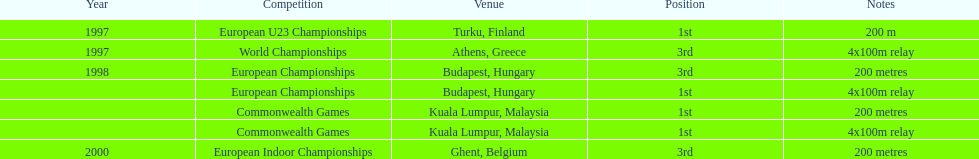List the other competitions besides european u23 championship that came in 1st position? European Championships, Commonwealth Games, Commonwealth Games. 